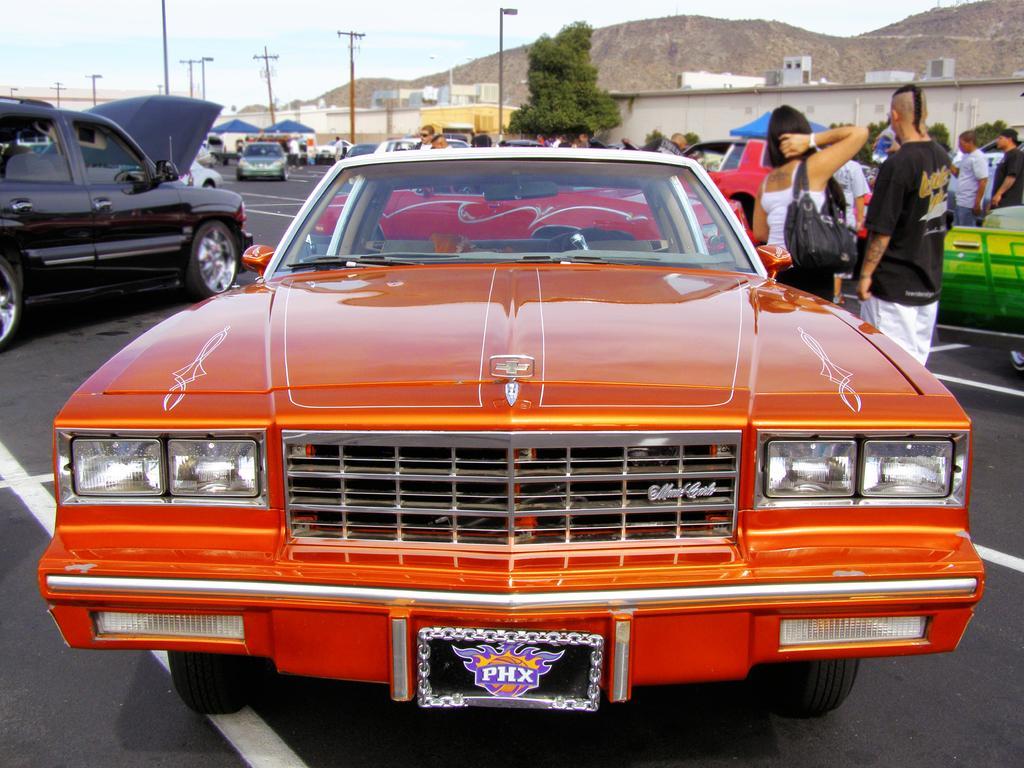How would you summarize this image in a sentence or two? In this image we can see a group of cars and some people standing on the road. We can also see the utility poles, trees, plants, walls, some buildings and the sky which looks cloudy. 